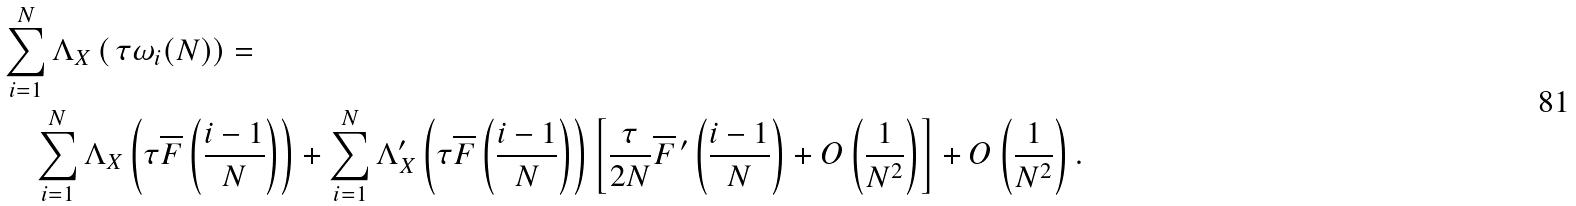<formula> <loc_0><loc_0><loc_500><loc_500>& \sum _ { i = 1 } ^ { N } \Lambda _ { X } \left ( \, \tau \omega _ { i } ( N ) \right ) = \\ & \quad \sum _ { i = 1 } ^ { N } \Lambda _ { X } \left ( \tau \overline { F } \left ( \frac { i - 1 } { N } \right ) \right ) + \sum _ { i = 1 } ^ { N } \Lambda _ { X } ^ { \prime } \left ( \tau \overline { F } \left ( \frac { i - 1 } { N } \right ) \right ) \left [ \frac { \tau } { 2 N } \overline { F } \, ^ { \prime } \left ( \frac { i - 1 } { N } \right ) + O \left ( \frac { 1 } { N ^ { 2 } } \right ) \right ] + O \left ( \frac { 1 } { N ^ { 2 } } \right ) .</formula> 